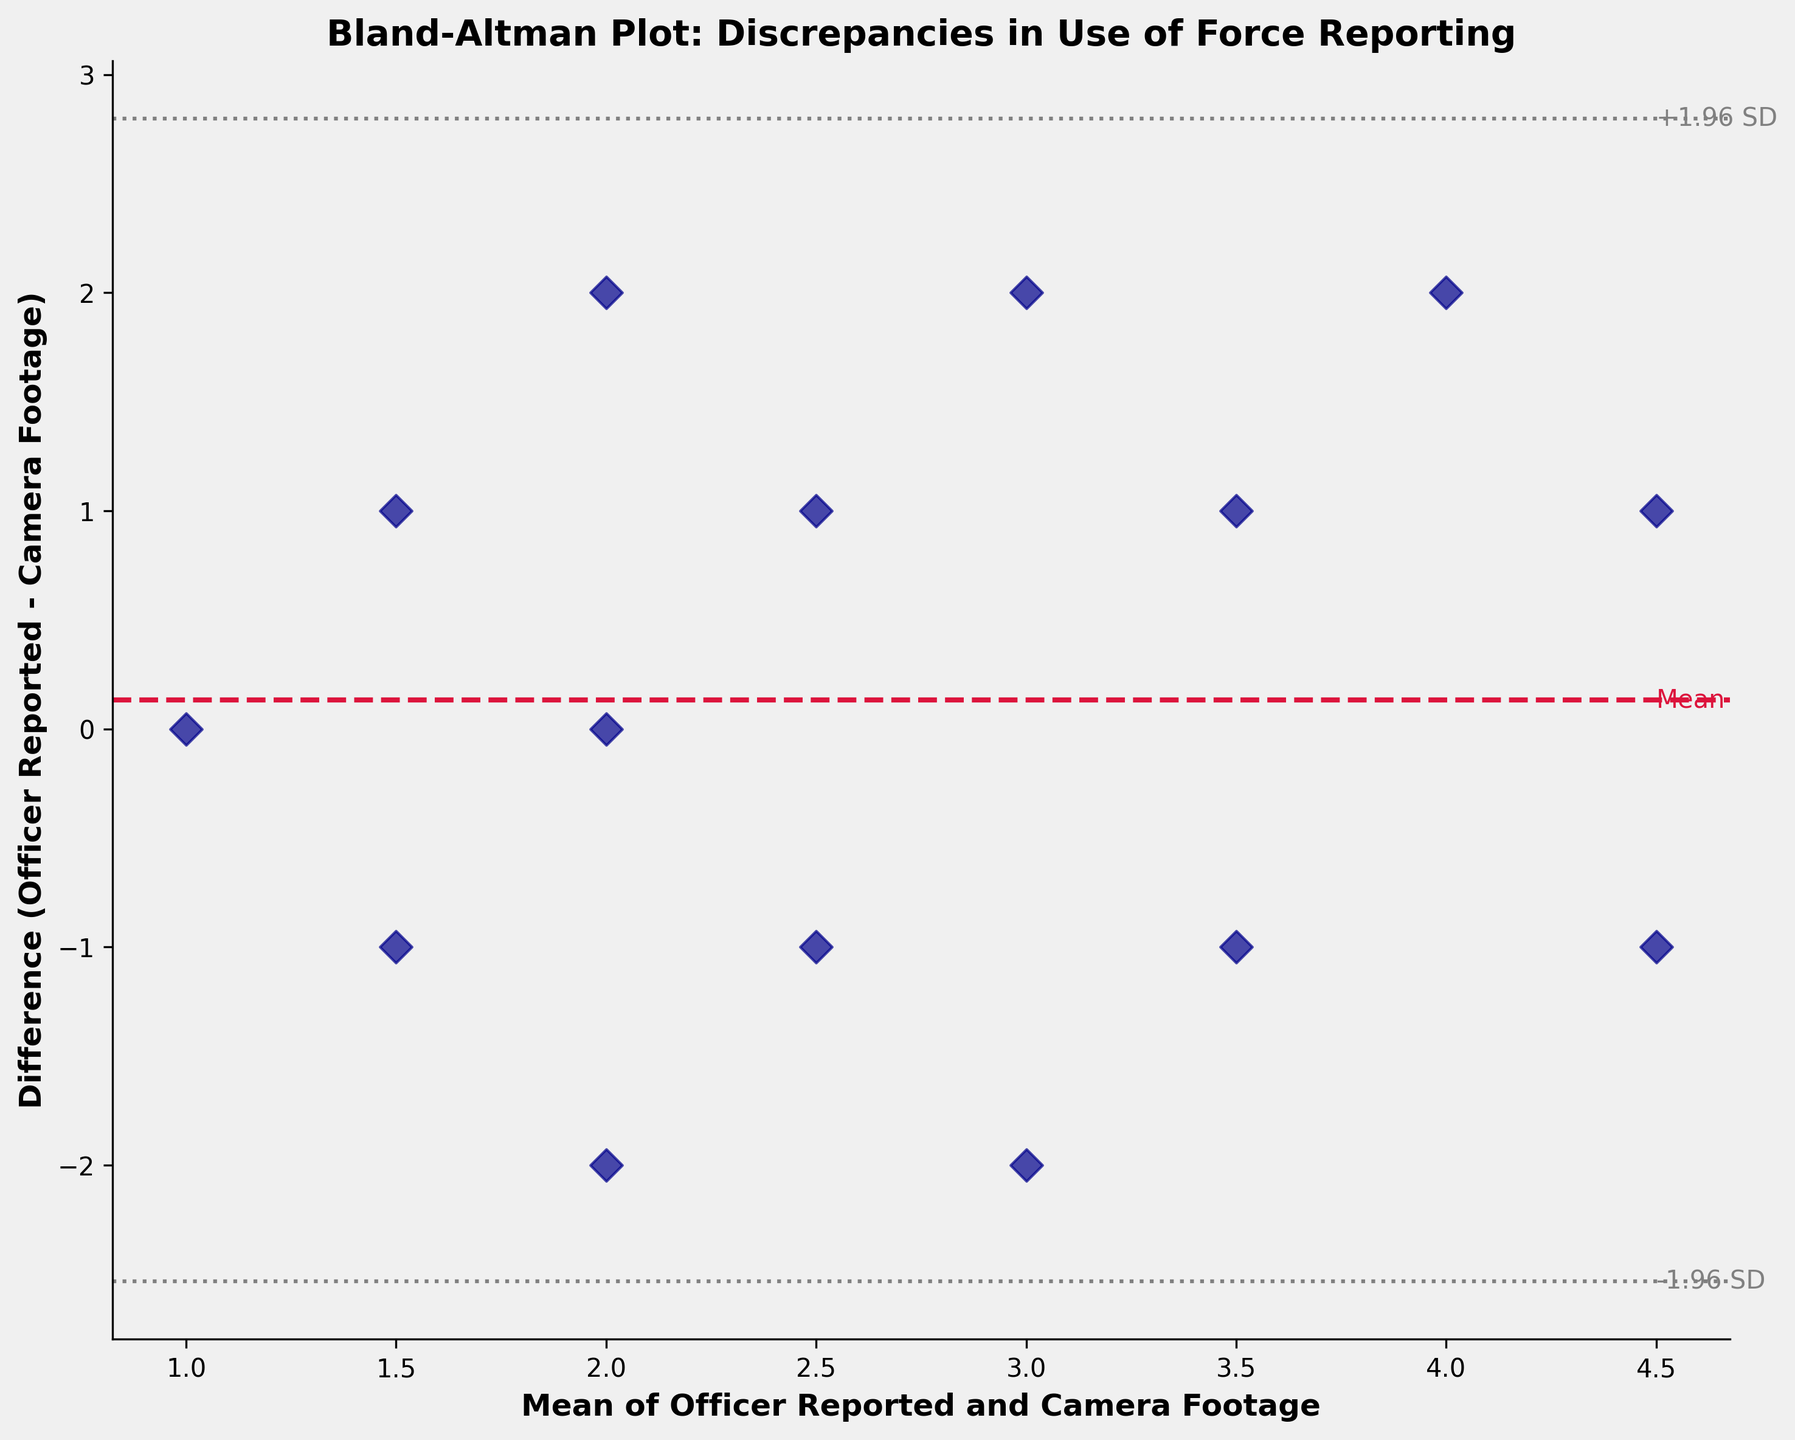What is the title of the figure? The title of the figure is typically located at the top center of the plot. In this figure, it says "Bland-Altman Plot: Discrepancies in Use of Force Reporting".
Answer: Bland-Altman Plot: Discrepancies in Use of Force Reporting How many data points are plotted in the figure? The number of data points can be determined by counting the number of markers (dark blue diamonds) in the plot. There are 15 markers visible in the figure.
Answer: 15 What is the mean difference between officer-reported incidents and camera footage? The mean difference (md) is represented by the crimson dashed line on the plot. This line is labeled as "Mean". The exact value isn't specified in the figure itself, but it's marked by a horizontal line.
Answer: Marked by a horizontal crimson dashed line What do the gray dotted lines represent on the plot? The gray dotted lines represent limits of agreement, specifically the mean difference plus and minus 1.96 times the standard deviation (±1.96 SD). These lines indicate the range within which 95% of the differences between methods fall.
Answer: Limits of agreement Which data point shows the highest positive discrepancy? The highest positive discrepancy is the data point with the largest vertical distance above the mean difference line (crimson dashed line). This data point represents a reported incident count of 2 for "Camera Footage" and 4 for "Officer Reported" (mean = 3), yielding a difference of +2.
Answer: Difference of +2 What is the label of the x-axis? The label of the x-axis is found along the horizontal axis. It reads "Mean of Officer Reported and Camera Footage", which describes the average value of the two methods.
Answer: Mean of Officer Reported and Camera Footage What does a point below the mean difference line indicate? Points below the mean difference line indicate cases where the officer-reported use of force is less than what is seen in the camera footage (negative difference).
Answer: Officer-reported less than camera footage Are there more points above or below the mean difference line? To determine if there are more points above or below the mean difference line, one needs to count the points on either side of the crimson dashed line. From visual inspection, there are 6 points above and 9 points below the line.
Answer: More points below What is the range of the x-axis in the plot? The range of the x-axis can be estimated by looking at the leftmost and rightmost values along the axis labeled "Mean of Officer Reported and Camera Footage". The range appears to span from just below 1 to just above 4.5.
Answer: Just below 1 to just above 4.5 Which officer has the data point closest to the mean difference line and what does it represent? The closest data point to the mean difference line (labeled "Mean") would be one with a small difference between the officer-reported and camera footage numbers. For instance, Sarah Johnson (2 reported, 3 on camera) has a difference of -1 and is visually near the mean difference line.
Answer: Sarah Johnson, Difference of -1 